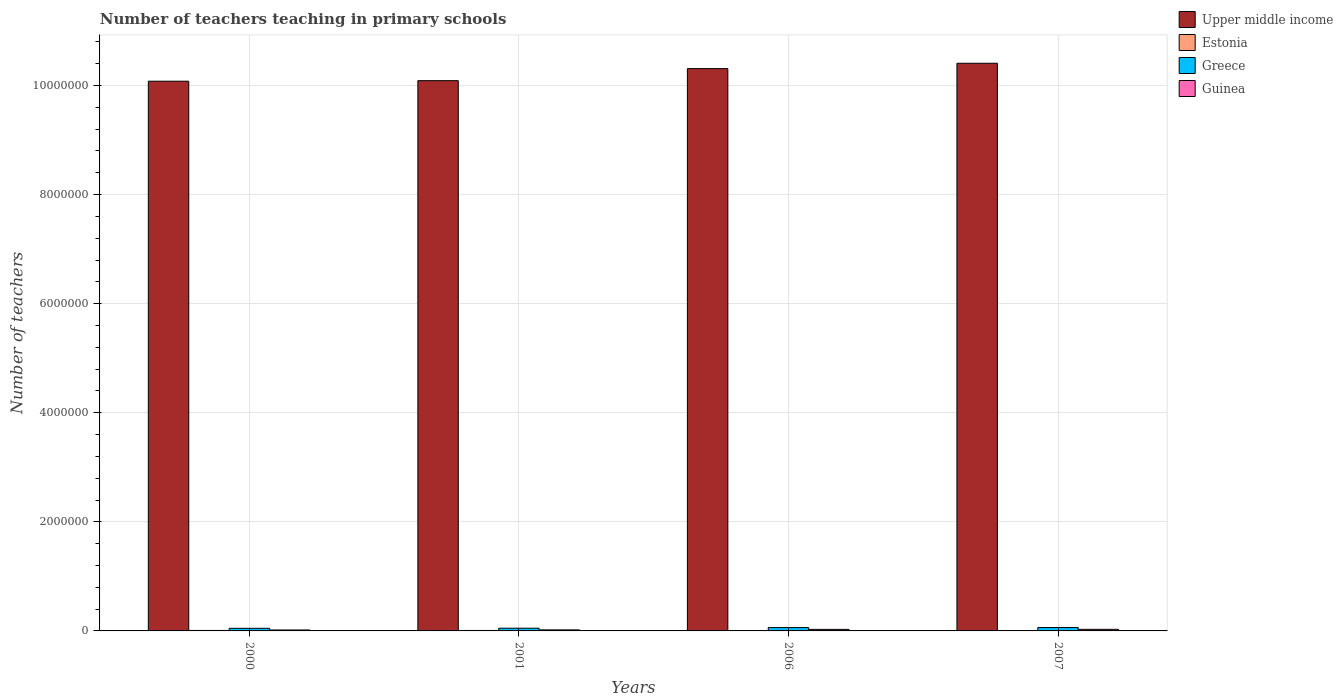Are the number of bars on each tick of the X-axis equal?
Provide a succinct answer. Yes. How many bars are there on the 4th tick from the left?
Your response must be concise. 4. How many bars are there on the 1st tick from the right?
Offer a very short reply. 4. What is the label of the 3rd group of bars from the left?
Keep it short and to the point. 2006. What is the number of teachers teaching in primary schools in Estonia in 2001?
Give a very brief answer. 8315. Across all years, what is the maximum number of teachers teaching in primary schools in Guinea?
Make the answer very short. 2.90e+04. Across all years, what is the minimum number of teachers teaching in primary schools in Greece?
Provide a succinct answer. 4.81e+04. What is the total number of teachers teaching in primary schools in Estonia in the graph?
Offer a very short reply. 3.04e+04. What is the difference between the number of teachers teaching in primary schools in Greece in 2000 and that in 2007?
Your answer should be compact. -1.40e+04. What is the difference between the number of teachers teaching in primary schools in Greece in 2007 and the number of teachers teaching in primary schools in Upper middle income in 2001?
Your response must be concise. -1.00e+07. What is the average number of teachers teaching in primary schools in Guinea per year?
Make the answer very short. 2.35e+04. In the year 2000, what is the difference between the number of teachers teaching in primary schools in Estonia and number of teachers teaching in primary schools in Upper middle income?
Keep it short and to the point. -1.01e+07. What is the ratio of the number of teachers teaching in primary schools in Upper middle income in 2006 to that in 2007?
Provide a short and direct response. 0.99. Is the difference between the number of teachers teaching in primary schools in Estonia in 2006 and 2007 greater than the difference between the number of teachers teaching in primary schools in Upper middle income in 2006 and 2007?
Make the answer very short. Yes. What is the difference between the highest and the second highest number of teachers teaching in primary schools in Estonia?
Make the answer very short. 301. What is the difference between the highest and the lowest number of teachers teaching in primary schools in Guinea?
Your answer should be compact. 1.17e+04. In how many years, is the number of teachers teaching in primary schools in Upper middle income greater than the average number of teachers teaching in primary schools in Upper middle income taken over all years?
Offer a very short reply. 2. Is the sum of the number of teachers teaching in primary schools in Greece in 2001 and 2007 greater than the maximum number of teachers teaching in primary schools in Estonia across all years?
Ensure brevity in your answer.  Yes. Is it the case that in every year, the sum of the number of teachers teaching in primary schools in Upper middle income and number of teachers teaching in primary schools in Estonia is greater than the sum of number of teachers teaching in primary schools in Guinea and number of teachers teaching in primary schools in Greece?
Your answer should be compact. No. What does the 2nd bar from the right in 2006 represents?
Your answer should be very brief. Greece. Are all the bars in the graph horizontal?
Offer a terse response. No. How many years are there in the graph?
Offer a very short reply. 4. Does the graph contain any zero values?
Give a very brief answer. No. Where does the legend appear in the graph?
Keep it short and to the point. Top right. How many legend labels are there?
Provide a short and direct response. 4. What is the title of the graph?
Offer a very short reply. Number of teachers teaching in primary schools. Does "Middle East & North Africa (all income levels)" appear as one of the legend labels in the graph?
Provide a short and direct response. No. What is the label or title of the Y-axis?
Your answer should be compact. Number of teachers. What is the Number of teachers in Upper middle income in 2000?
Provide a succinct answer. 1.01e+07. What is the Number of teachers in Estonia in 2000?
Your response must be concise. 8616. What is the Number of teachers in Greece in 2000?
Your answer should be compact. 4.81e+04. What is the Number of teachers of Guinea in 2000?
Your answer should be compact. 1.73e+04. What is the Number of teachers in Upper middle income in 2001?
Your answer should be very brief. 1.01e+07. What is the Number of teachers of Estonia in 2001?
Offer a very short reply. 8315. What is the Number of teachers in Greece in 2001?
Your answer should be very brief. 5.00e+04. What is the Number of teachers of Guinea in 2001?
Your answer should be very brief. 1.92e+04. What is the Number of teachers of Upper middle income in 2006?
Offer a very short reply. 1.03e+07. What is the Number of teachers of Estonia in 2006?
Provide a short and direct response. 7516. What is the Number of teachers in Greece in 2006?
Provide a succinct answer. 6.13e+04. What is the Number of teachers in Guinea in 2006?
Provide a short and direct response. 2.83e+04. What is the Number of teachers in Upper middle income in 2007?
Your answer should be compact. 1.04e+07. What is the Number of teachers of Estonia in 2007?
Your answer should be compact. 5927. What is the Number of teachers in Greece in 2007?
Offer a terse response. 6.21e+04. What is the Number of teachers in Guinea in 2007?
Offer a terse response. 2.90e+04. Across all years, what is the maximum Number of teachers in Upper middle income?
Your response must be concise. 1.04e+07. Across all years, what is the maximum Number of teachers in Estonia?
Keep it short and to the point. 8616. Across all years, what is the maximum Number of teachers of Greece?
Offer a terse response. 6.21e+04. Across all years, what is the maximum Number of teachers in Guinea?
Give a very brief answer. 2.90e+04. Across all years, what is the minimum Number of teachers of Upper middle income?
Give a very brief answer. 1.01e+07. Across all years, what is the minimum Number of teachers of Estonia?
Your answer should be very brief. 5927. Across all years, what is the minimum Number of teachers in Greece?
Your answer should be very brief. 4.81e+04. Across all years, what is the minimum Number of teachers in Guinea?
Your response must be concise. 1.73e+04. What is the total Number of teachers in Upper middle income in the graph?
Offer a very short reply. 4.09e+07. What is the total Number of teachers in Estonia in the graph?
Offer a terse response. 3.04e+04. What is the total Number of teachers in Greece in the graph?
Give a very brief answer. 2.21e+05. What is the total Number of teachers in Guinea in the graph?
Your answer should be compact. 9.39e+04. What is the difference between the Number of teachers in Upper middle income in 2000 and that in 2001?
Offer a terse response. -9985. What is the difference between the Number of teachers in Estonia in 2000 and that in 2001?
Provide a succinct answer. 301. What is the difference between the Number of teachers of Greece in 2000 and that in 2001?
Give a very brief answer. -1908. What is the difference between the Number of teachers of Guinea in 2000 and that in 2001?
Offer a terse response. -1904. What is the difference between the Number of teachers of Upper middle income in 2000 and that in 2006?
Provide a short and direct response. -2.31e+05. What is the difference between the Number of teachers of Estonia in 2000 and that in 2006?
Your answer should be compact. 1100. What is the difference between the Number of teachers of Greece in 2000 and that in 2006?
Ensure brevity in your answer.  -1.31e+04. What is the difference between the Number of teachers of Guinea in 2000 and that in 2006?
Provide a short and direct response. -1.10e+04. What is the difference between the Number of teachers in Upper middle income in 2000 and that in 2007?
Your answer should be very brief. -3.29e+05. What is the difference between the Number of teachers of Estonia in 2000 and that in 2007?
Provide a succinct answer. 2689. What is the difference between the Number of teachers in Greece in 2000 and that in 2007?
Your answer should be very brief. -1.40e+04. What is the difference between the Number of teachers in Guinea in 2000 and that in 2007?
Your response must be concise. -1.17e+04. What is the difference between the Number of teachers in Upper middle income in 2001 and that in 2006?
Keep it short and to the point. -2.21e+05. What is the difference between the Number of teachers in Estonia in 2001 and that in 2006?
Offer a very short reply. 799. What is the difference between the Number of teachers in Greece in 2001 and that in 2006?
Your answer should be very brief. -1.12e+04. What is the difference between the Number of teachers in Guinea in 2001 and that in 2006?
Offer a very short reply. -9052. What is the difference between the Number of teachers in Upper middle income in 2001 and that in 2007?
Your answer should be very brief. -3.19e+05. What is the difference between the Number of teachers of Estonia in 2001 and that in 2007?
Offer a terse response. 2388. What is the difference between the Number of teachers of Greece in 2001 and that in 2007?
Provide a succinct answer. -1.21e+04. What is the difference between the Number of teachers in Guinea in 2001 and that in 2007?
Your response must be concise. -9805. What is the difference between the Number of teachers of Upper middle income in 2006 and that in 2007?
Provide a short and direct response. -9.83e+04. What is the difference between the Number of teachers of Estonia in 2006 and that in 2007?
Your answer should be very brief. 1589. What is the difference between the Number of teachers of Greece in 2006 and that in 2007?
Give a very brief answer. -863. What is the difference between the Number of teachers in Guinea in 2006 and that in 2007?
Give a very brief answer. -753. What is the difference between the Number of teachers in Upper middle income in 2000 and the Number of teachers in Estonia in 2001?
Provide a succinct answer. 1.01e+07. What is the difference between the Number of teachers of Upper middle income in 2000 and the Number of teachers of Greece in 2001?
Keep it short and to the point. 1.00e+07. What is the difference between the Number of teachers in Upper middle income in 2000 and the Number of teachers in Guinea in 2001?
Ensure brevity in your answer.  1.01e+07. What is the difference between the Number of teachers in Estonia in 2000 and the Number of teachers in Greece in 2001?
Your response must be concise. -4.14e+04. What is the difference between the Number of teachers of Estonia in 2000 and the Number of teachers of Guinea in 2001?
Your answer should be compact. -1.06e+04. What is the difference between the Number of teachers of Greece in 2000 and the Number of teachers of Guinea in 2001?
Your response must be concise. 2.89e+04. What is the difference between the Number of teachers of Upper middle income in 2000 and the Number of teachers of Estonia in 2006?
Your answer should be very brief. 1.01e+07. What is the difference between the Number of teachers in Upper middle income in 2000 and the Number of teachers in Greece in 2006?
Provide a succinct answer. 1.00e+07. What is the difference between the Number of teachers of Upper middle income in 2000 and the Number of teachers of Guinea in 2006?
Provide a short and direct response. 1.01e+07. What is the difference between the Number of teachers in Estonia in 2000 and the Number of teachers in Greece in 2006?
Offer a very short reply. -5.26e+04. What is the difference between the Number of teachers of Estonia in 2000 and the Number of teachers of Guinea in 2006?
Your response must be concise. -1.97e+04. What is the difference between the Number of teachers of Greece in 2000 and the Number of teachers of Guinea in 2006?
Offer a terse response. 1.98e+04. What is the difference between the Number of teachers of Upper middle income in 2000 and the Number of teachers of Estonia in 2007?
Offer a very short reply. 1.01e+07. What is the difference between the Number of teachers of Upper middle income in 2000 and the Number of teachers of Greece in 2007?
Provide a succinct answer. 1.00e+07. What is the difference between the Number of teachers in Upper middle income in 2000 and the Number of teachers in Guinea in 2007?
Provide a short and direct response. 1.01e+07. What is the difference between the Number of teachers of Estonia in 2000 and the Number of teachers of Greece in 2007?
Give a very brief answer. -5.35e+04. What is the difference between the Number of teachers in Estonia in 2000 and the Number of teachers in Guinea in 2007?
Provide a short and direct response. -2.04e+04. What is the difference between the Number of teachers in Greece in 2000 and the Number of teachers in Guinea in 2007?
Ensure brevity in your answer.  1.91e+04. What is the difference between the Number of teachers in Upper middle income in 2001 and the Number of teachers in Estonia in 2006?
Keep it short and to the point. 1.01e+07. What is the difference between the Number of teachers of Upper middle income in 2001 and the Number of teachers of Greece in 2006?
Make the answer very short. 1.00e+07. What is the difference between the Number of teachers in Upper middle income in 2001 and the Number of teachers in Guinea in 2006?
Offer a terse response. 1.01e+07. What is the difference between the Number of teachers of Estonia in 2001 and the Number of teachers of Greece in 2006?
Your answer should be very brief. -5.29e+04. What is the difference between the Number of teachers of Estonia in 2001 and the Number of teachers of Guinea in 2006?
Make the answer very short. -2.00e+04. What is the difference between the Number of teachers of Greece in 2001 and the Number of teachers of Guinea in 2006?
Offer a terse response. 2.17e+04. What is the difference between the Number of teachers in Upper middle income in 2001 and the Number of teachers in Estonia in 2007?
Offer a terse response. 1.01e+07. What is the difference between the Number of teachers of Upper middle income in 2001 and the Number of teachers of Greece in 2007?
Offer a very short reply. 1.00e+07. What is the difference between the Number of teachers in Upper middle income in 2001 and the Number of teachers in Guinea in 2007?
Provide a succinct answer. 1.01e+07. What is the difference between the Number of teachers of Estonia in 2001 and the Number of teachers of Greece in 2007?
Ensure brevity in your answer.  -5.38e+04. What is the difference between the Number of teachers of Estonia in 2001 and the Number of teachers of Guinea in 2007?
Your answer should be compact. -2.07e+04. What is the difference between the Number of teachers of Greece in 2001 and the Number of teachers of Guinea in 2007?
Provide a short and direct response. 2.10e+04. What is the difference between the Number of teachers of Upper middle income in 2006 and the Number of teachers of Estonia in 2007?
Give a very brief answer. 1.03e+07. What is the difference between the Number of teachers of Upper middle income in 2006 and the Number of teachers of Greece in 2007?
Give a very brief answer. 1.02e+07. What is the difference between the Number of teachers in Upper middle income in 2006 and the Number of teachers in Guinea in 2007?
Offer a terse response. 1.03e+07. What is the difference between the Number of teachers of Estonia in 2006 and the Number of teachers of Greece in 2007?
Your response must be concise. -5.46e+04. What is the difference between the Number of teachers in Estonia in 2006 and the Number of teachers in Guinea in 2007?
Give a very brief answer. -2.15e+04. What is the difference between the Number of teachers of Greece in 2006 and the Number of teachers of Guinea in 2007?
Provide a succinct answer. 3.22e+04. What is the average Number of teachers in Upper middle income per year?
Give a very brief answer. 1.02e+07. What is the average Number of teachers of Estonia per year?
Give a very brief answer. 7593.5. What is the average Number of teachers of Greece per year?
Offer a very short reply. 5.54e+04. What is the average Number of teachers in Guinea per year?
Keep it short and to the point. 2.35e+04. In the year 2000, what is the difference between the Number of teachers in Upper middle income and Number of teachers in Estonia?
Make the answer very short. 1.01e+07. In the year 2000, what is the difference between the Number of teachers in Upper middle income and Number of teachers in Greece?
Your response must be concise. 1.00e+07. In the year 2000, what is the difference between the Number of teachers in Upper middle income and Number of teachers in Guinea?
Offer a very short reply. 1.01e+07. In the year 2000, what is the difference between the Number of teachers in Estonia and Number of teachers in Greece?
Your answer should be compact. -3.95e+04. In the year 2000, what is the difference between the Number of teachers in Estonia and Number of teachers in Guinea?
Provide a short and direct response. -8724. In the year 2000, what is the difference between the Number of teachers of Greece and Number of teachers of Guinea?
Provide a short and direct response. 3.08e+04. In the year 2001, what is the difference between the Number of teachers in Upper middle income and Number of teachers in Estonia?
Ensure brevity in your answer.  1.01e+07. In the year 2001, what is the difference between the Number of teachers of Upper middle income and Number of teachers of Greece?
Your response must be concise. 1.00e+07. In the year 2001, what is the difference between the Number of teachers in Upper middle income and Number of teachers in Guinea?
Offer a terse response. 1.01e+07. In the year 2001, what is the difference between the Number of teachers of Estonia and Number of teachers of Greece?
Keep it short and to the point. -4.17e+04. In the year 2001, what is the difference between the Number of teachers of Estonia and Number of teachers of Guinea?
Your response must be concise. -1.09e+04. In the year 2001, what is the difference between the Number of teachers of Greece and Number of teachers of Guinea?
Your answer should be very brief. 3.08e+04. In the year 2006, what is the difference between the Number of teachers in Upper middle income and Number of teachers in Estonia?
Keep it short and to the point. 1.03e+07. In the year 2006, what is the difference between the Number of teachers of Upper middle income and Number of teachers of Greece?
Provide a short and direct response. 1.02e+07. In the year 2006, what is the difference between the Number of teachers of Upper middle income and Number of teachers of Guinea?
Your response must be concise. 1.03e+07. In the year 2006, what is the difference between the Number of teachers of Estonia and Number of teachers of Greece?
Your answer should be very brief. -5.37e+04. In the year 2006, what is the difference between the Number of teachers of Estonia and Number of teachers of Guinea?
Give a very brief answer. -2.08e+04. In the year 2006, what is the difference between the Number of teachers in Greece and Number of teachers in Guinea?
Offer a very short reply. 3.30e+04. In the year 2007, what is the difference between the Number of teachers in Upper middle income and Number of teachers in Estonia?
Provide a short and direct response. 1.04e+07. In the year 2007, what is the difference between the Number of teachers of Upper middle income and Number of teachers of Greece?
Keep it short and to the point. 1.03e+07. In the year 2007, what is the difference between the Number of teachers in Upper middle income and Number of teachers in Guinea?
Ensure brevity in your answer.  1.04e+07. In the year 2007, what is the difference between the Number of teachers in Estonia and Number of teachers in Greece?
Provide a short and direct response. -5.62e+04. In the year 2007, what is the difference between the Number of teachers of Estonia and Number of teachers of Guinea?
Offer a very short reply. -2.31e+04. In the year 2007, what is the difference between the Number of teachers of Greece and Number of teachers of Guinea?
Provide a short and direct response. 3.31e+04. What is the ratio of the Number of teachers in Estonia in 2000 to that in 2001?
Keep it short and to the point. 1.04. What is the ratio of the Number of teachers of Greece in 2000 to that in 2001?
Keep it short and to the point. 0.96. What is the ratio of the Number of teachers in Guinea in 2000 to that in 2001?
Your response must be concise. 0.9. What is the ratio of the Number of teachers of Upper middle income in 2000 to that in 2006?
Keep it short and to the point. 0.98. What is the ratio of the Number of teachers in Estonia in 2000 to that in 2006?
Your answer should be compact. 1.15. What is the ratio of the Number of teachers in Greece in 2000 to that in 2006?
Give a very brief answer. 0.79. What is the ratio of the Number of teachers of Guinea in 2000 to that in 2006?
Provide a short and direct response. 0.61. What is the ratio of the Number of teachers in Upper middle income in 2000 to that in 2007?
Make the answer very short. 0.97. What is the ratio of the Number of teachers in Estonia in 2000 to that in 2007?
Your answer should be very brief. 1.45. What is the ratio of the Number of teachers in Greece in 2000 to that in 2007?
Keep it short and to the point. 0.77. What is the ratio of the Number of teachers in Guinea in 2000 to that in 2007?
Give a very brief answer. 0.6. What is the ratio of the Number of teachers of Upper middle income in 2001 to that in 2006?
Offer a very short reply. 0.98. What is the ratio of the Number of teachers in Estonia in 2001 to that in 2006?
Your answer should be compact. 1.11. What is the ratio of the Number of teachers in Greece in 2001 to that in 2006?
Ensure brevity in your answer.  0.82. What is the ratio of the Number of teachers of Guinea in 2001 to that in 2006?
Keep it short and to the point. 0.68. What is the ratio of the Number of teachers of Upper middle income in 2001 to that in 2007?
Provide a short and direct response. 0.97. What is the ratio of the Number of teachers of Estonia in 2001 to that in 2007?
Provide a succinct answer. 1.4. What is the ratio of the Number of teachers in Greece in 2001 to that in 2007?
Provide a succinct answer. 0.81. What is the ratio of the Number of teachers of Guinea in 2001 to that in 2007?
Your answer should be very brief. 0.66. What is the ratio of the Number of teachers in Upper middle income in 2006 to that in 2007?
Offer a terse response. 0.99. What is the ratio of the Number of teachers of Estonia in 2006 to that in 2007?
Make the answer very short. 1.27. What is the ratio of the Number of teachers in Greece in 2006 to that in 2007?
Give a very brief answer. 0.99. What is the ratio of the Number of teachers of Guinea in 2006 to that in 2007?
Your answer should be compact. 0.97. What is the difference between the highest and the second highest Number of teachers in Upper middle income?
Make the answer very short. 9.83e+04. What is the difference between the highest and the second highest Number of teachers in Estonia?
Give a very brief answer. 301. What is the difference between the highest and the second highest Number of teachers in Greece?
Offer a terse response. 863. What is the difference between the highest and the second highest Number of teachers in Guinea?
Your answer should be compact. 753. What is the difference between the highest and the lowest Number of teachers in Upper middle income?
Provide a succinct answer. 3.29e+05. What is the difference between the highest and the lowest Number of teachers in Estonia?
Your answer should be very brief. 2689. What is the difference between the highest and the lowest Number of teachers in Greece?
Make the answer very short. 1.40e+04. What is the difference between the highest and the lowest Number of teachers of Guinea?
Provide a short and direct response. 1.17e+04. 